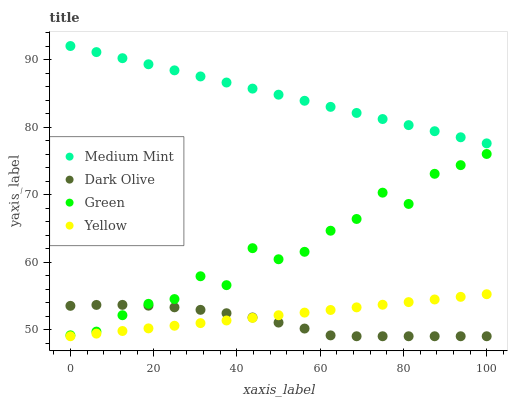Does Dark Olive have the minimum area under the curve?
Answer yes or no. Yes. Does Medium Mint have the maximum area under the curve?
Answer yes or no. Yes. Does Green have the minimum area under the curve?
Answer yes or no. No. Does Green have the maximum area under the curve?
Answer yes or no. No. Is Yellow the smoothest?
Answer yes or no. Yes. Is Green the roughest?
Answer yes or no. Yes. Is Dark Olive the smoothest?
Answer yes or no. No. Is Dark Olive the roughest?
Answer yes or no. No. Does Dark Olive have the lowest value?
Answer yes or no. Yes. Does Green have the lowest value?
Answer yes or no. No. Does Medium Mint have the highest value?
Answer yes or no. Yes. Does Green have the highest value?
Answer yes or no. No. Is Yellow less than Green?
Answer yes or no. Yes. Is Green greater than Yellow?
Answer yes or no. Yes. Does Green intersect Dark Olive?
Answer yes or no. Yes. Is Green less than Dark Olive?
Answer yes or no. No. Is Green greater than Dark Olive?
Answer yes or no. No. Does Yellow intersect Green?
Answer yes or no. No. 